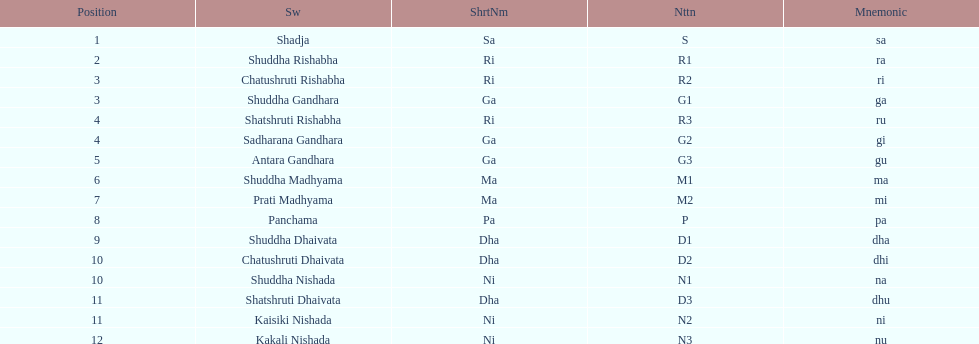What is the total number of positions listed? 16. 